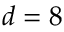Convert formula to latex. <formula><loc_0><loc_0><loc_500><loc_500>d = 8</formula> 